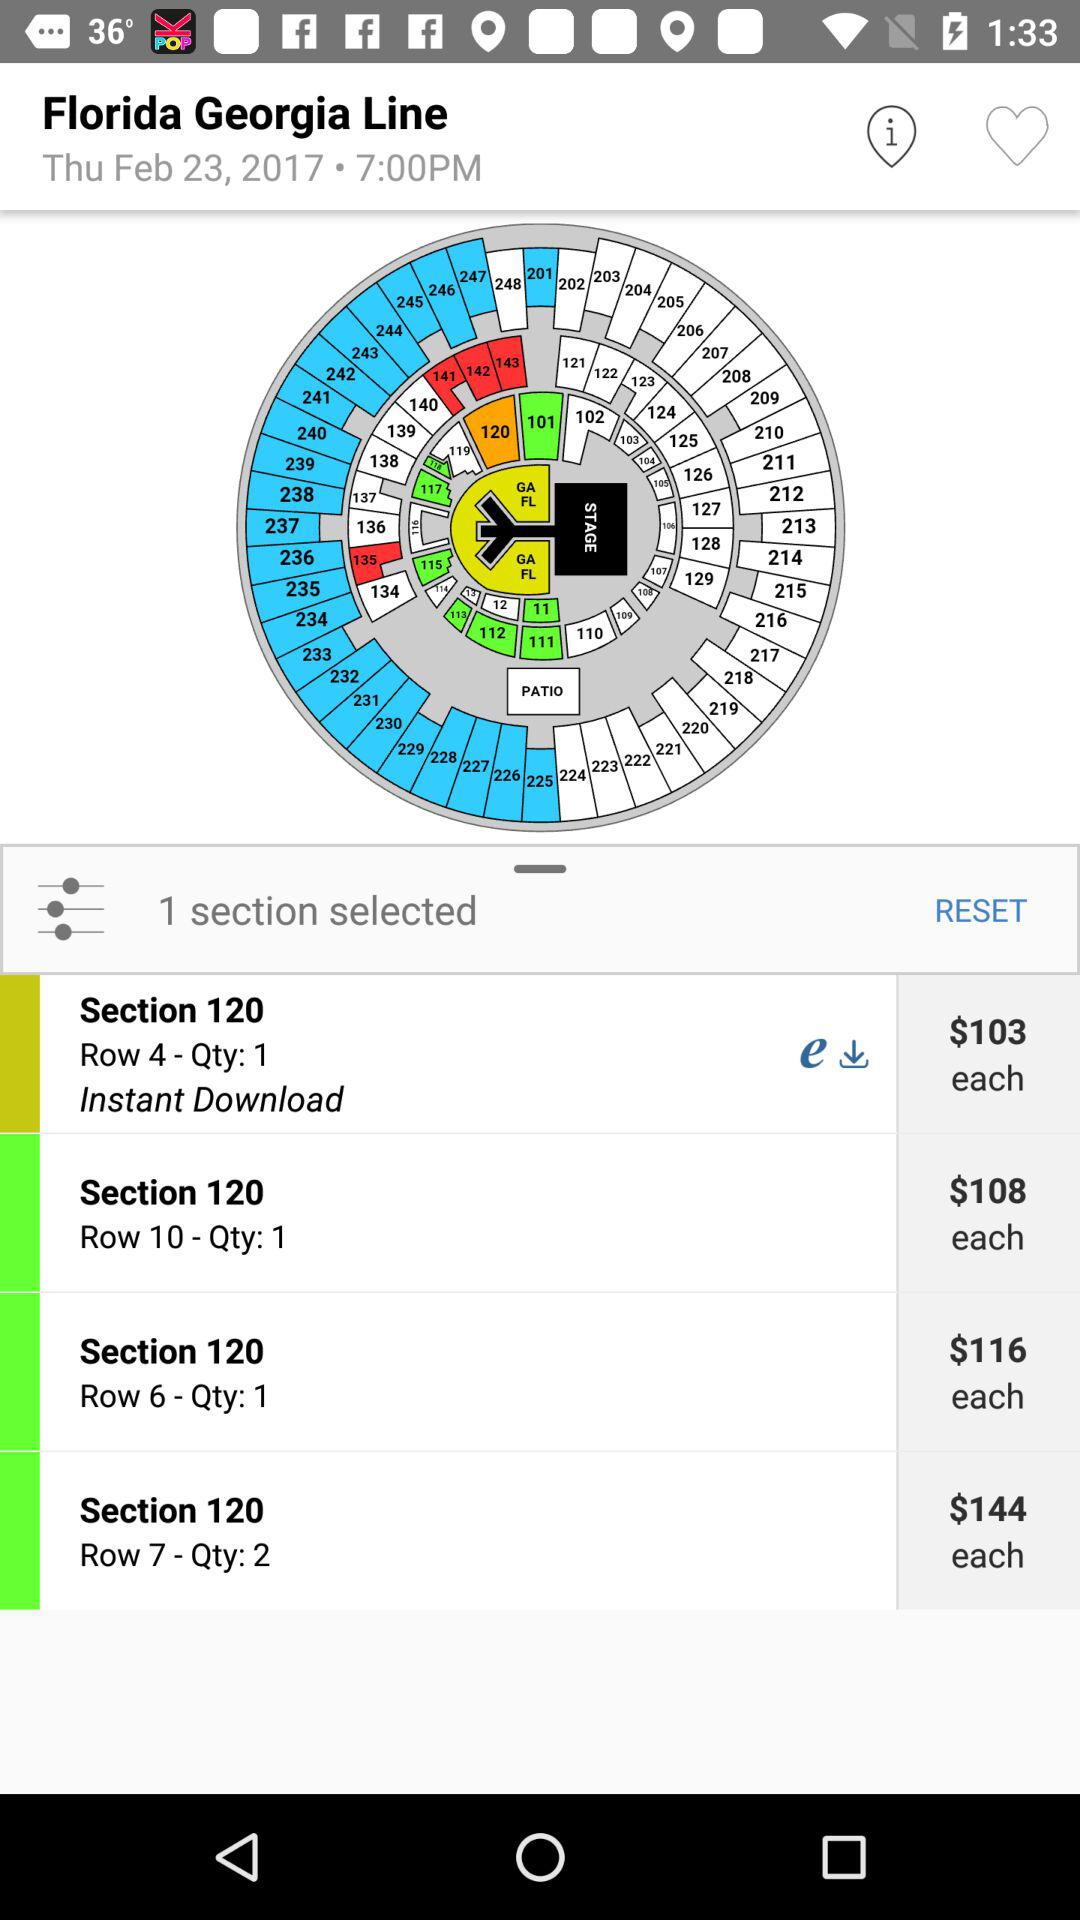Which section has the "Instant Download" option? The section is 120. 